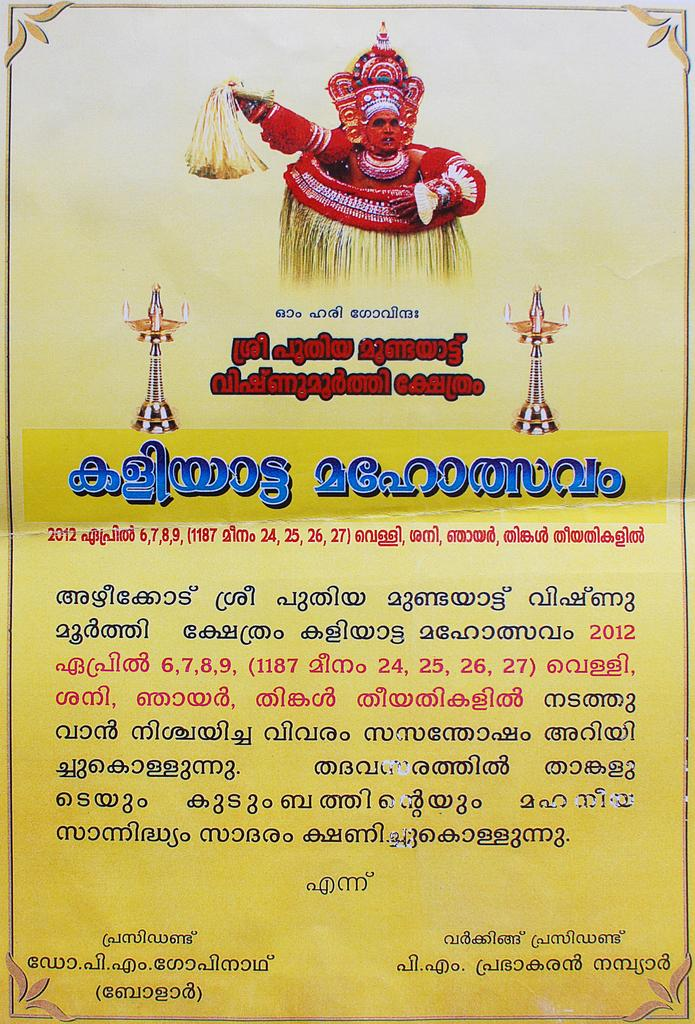What can be seen on the poster in the image? There is a poster in the image, and it contains text in different languages. Can you describe the man in the image? The man in the image is wearing traditional dress of Kerala. Is there a flame visible in the image? No, there is no flame present in the image. Are the man and the poster engaged in an argument in the image? No, there is no indication of an argument between the man and the poster in the image. 